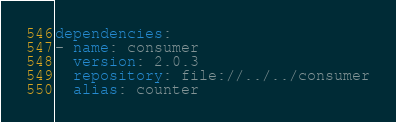<code> <loc_0><loc_0><loc_500><loc_500><_YAML_>dependencies:
- name: consumer
  version: 2.0.3
  repository: file://../../consumer
  alias: counter
</code> 